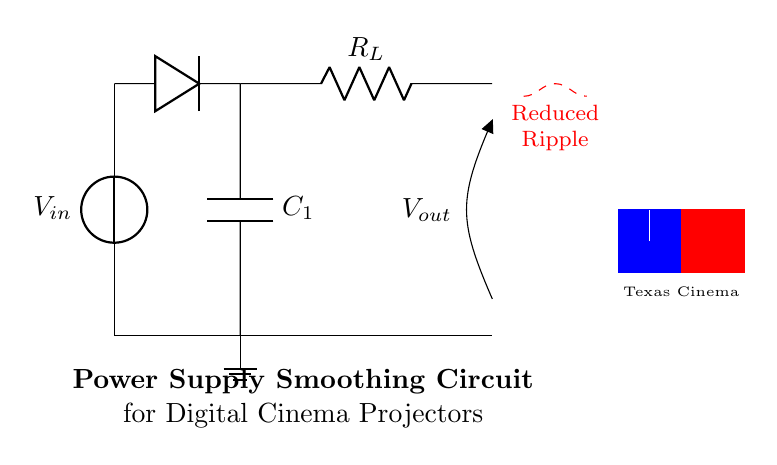What is the input voltage of the circuit? The circuit clearly has a voltage source labeled V_{in}, which represents the input voltage. Therefore, the input voltage is V_{in} as specified in the diagram.
Answer: V_{in} What component smooths the voltage in this circuit? The smoothing capacitor, labeled C_1, is responsible for reducing the voltage ripple, which implies its function is to smooth the output.
Answer: C_1 What type of circuit is shown here? The circuit is a power supply smoothing circuit, specifically utilizing a Resistor-Capacitor configuration to stabilize output voltage.
Answer: Power supply smoothing circuit How many circuit components are depicted in the diagram? The diagram consists of a voltage source, a diode, a capacitor, a resistor, and ground connections. Counting these, there are four main components.
Answer: Four What is the role of the load resistor in this circuit? The load resistor, labeled R_L, serves to dissipate power and allows measurement of the output voltage, thereby indicating its function in the circuit.
Answer: Dissipate power What effect does the smoothing capacitor have on ripple voltage? The diagram indicates a reduced ripple marked with a dashed line, suggesting that the presence of the smoothing capacitor decreases fluctuations in the output voltage, resulting in smoother output.
Answer: Reduced ripple What does V_{out} represent in this circuit? V_{out} denotes the output voltage across the load resistor, which is an essential reference point for the circuit's output performance.
Answer: Output voltage 